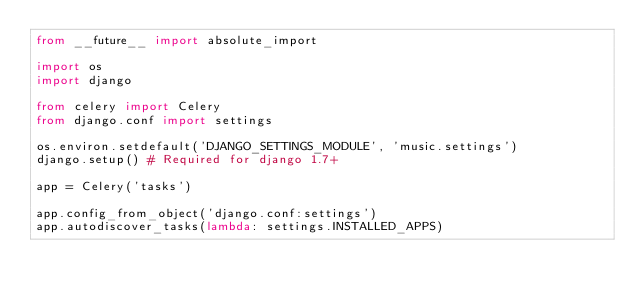<code> <loc_0><loc_0><loc_500><loc_500><_Python_>from __future__ import absolute_import

import os
import django

from celery import Celery
from django.conf import settings

os.environ.setdefault('DJANGO_SETTINGS_MODULE', 'music.settings')
django.setup() # Required for django 1.7+

app = Celery('tasks')

app.config_from_object('django.conf:settings')
app.autodiscover_tasks(lambda: settings.INSTALLED_APPS)</code> 